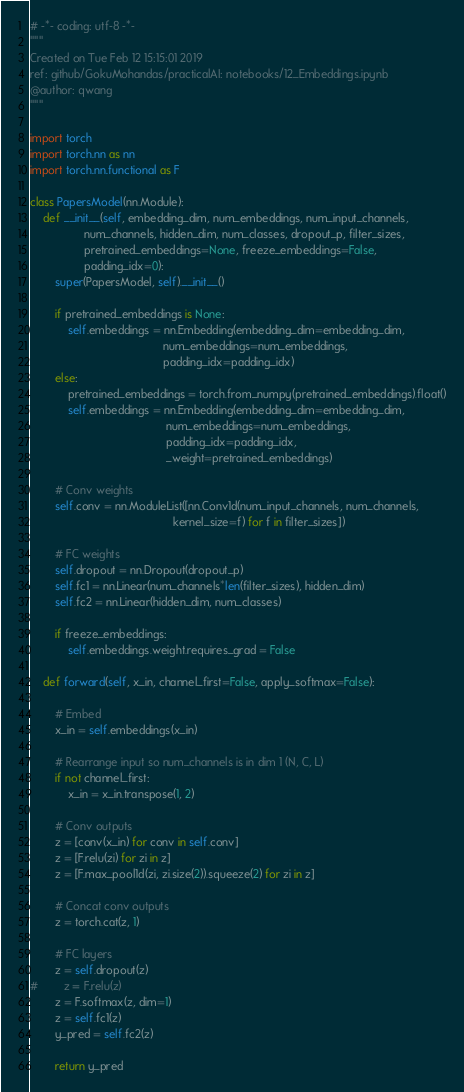<code> <loc_0><loc_0><loc_500><loc_500><_Python_># -*- coding: utf-8 -*-
"""
Created on Tue Feb 12 15:15:01 2019
ref: github/GokuMohandas/practicalAI: notebooks/12_Embeddings.ipynb
@author: qwang
"""

import torch
import torch.nn as nn
import torch.nn.functional as F

class PapersModel(nn.Module):
    def __init__(self, embedding_dim, num_embeddings, num_input_channels, 
                 num_channels, hidden_dim, num_classes, dropout_p, filter_sizes,
                 pretrained_embeddings=None, freeze_embeddings=False,
                 padding_idx=0):
        super(PapersModel, self).__init__()
        
        if pretrained_embeddings is None:
            self.embeddings = nn.Embedding(embedding_dim=embedding_dim,
                                          num_embeddings=num_embeddings,
                                          padding_idx=padding_idx)
        else:
            pretrained_embeddings = torch.from_numpy(pretrained_embeddings).float()
            self.embeddings = nn.Embedding(embedding_dim=embedding_dim,
                                           num_embeddings=num_embeddings,
                                           padding_idx=padding_idx,
                                           _weight=pretrained_embeddings)
        
        # Conv weights
        self.conv = nn.ModuleList([nn.Conv1d(num_input_channels, num_channels, 
                                             kernel_size=f) for f in filter_sizes])
     
        # FC weights
        self.dropout = nn.Dropout(dropout_p)
        self.fc1 = nn.Linear(num_channels*len(filter_sizes), hidden_dim)
        self.fc2 = nn.Linear(hidden_dim, num_classes)
        
        if freeze_embeddings:
            self.embeddings.weight.requires_grad = False

    def forward(self, x_in, channel_first=False, apply_softmax=False):
        
        # Embed
        x_in = self.embeddings(x_in)

        # Rearrange input so num_channels is in dim 1 (N, C, L)
        if not channel_first:
            x_in = x_in.transpose(1, 2)
            
        # Conv outputs        
        z = [conv(x_in) for conv in self.conv]
        z = [F.relu(zi) for zi in z]
        z = [F.max_pool1d(zi, zi.size(2)).squeeze(2) for zi in z]
               
        # Concat conv outputs
        z = torch.cat(z, 1)

        # FC layers
        z = self.dropout(z)
#        z = F.relu(z)
        z = F.softmax(z, dim=1)        
        z = self.fc1(z)    
        y_pred = self.fc2(z)

        return y_pred</code> 